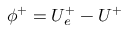<formula> <loc_0><loc_0><loc_500><loc_500>\phi ^ { + } = U _ { e } ^ { + } - U ^ { + }</formula> 